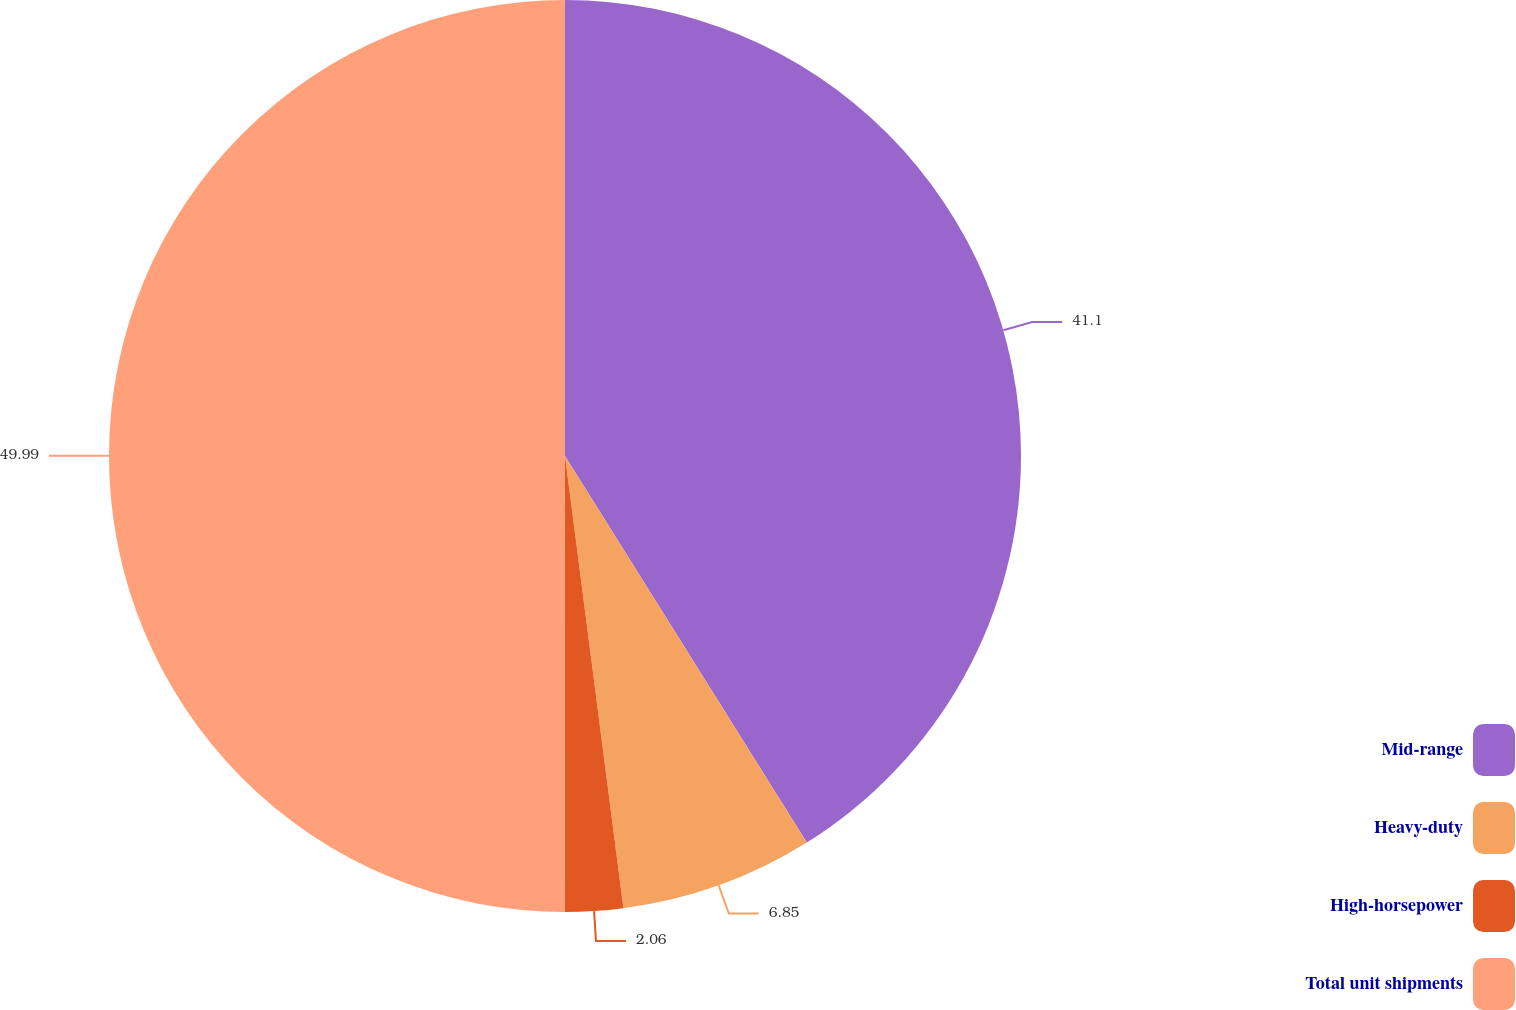<chart> <loc_0><loc_0><loc_500><loc_500><pie_chart><fcel>Mid-range<fcel>Heavy-duty<fcel>High-horsepower<fcel>Total unit shipments<nl><fcel>41.1%<fcel>6.85%<fcel>2.06%<fcel>49.98%<nl></chart> 